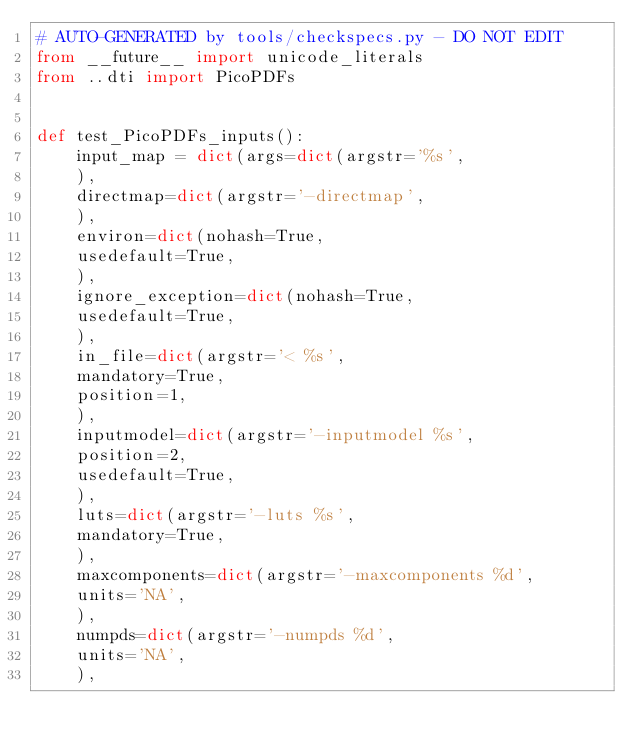<code> <loc_0><loc_0><loc_500><loc_500><_Python_># AUTO-GENERATED by tools/checkspecs.py - DO NOT EDIT
from __future__ import unicode_literals
from ..dti import PicoPDFs


def test_PicoPDFs_inputs():
    input_map = dict(args=dict(argstr='%s',
    ),
    directmap=dict(argstr='-directmap',
    ),
    environ=dict(nohash=True,
    usedefault=True,
    ),
    ignore_exception=dict(nohash=True,
    usedefault=True,
    ),
    in_file=dict(argstr='< %s',
    mandatory=True,
    position=1,
    ),
    inputmodel=dict(argstr='-inputmodel %s',
    position=2,
    usedefault=True,
    ),
    luts=dict(argstr='-luts %s',
    mandatory=True,
    ),
    maxcomponents=dict(argstr='-maxcomponents %d',
    units='NA',
    ),
    numpds=dict(argstr='-numpds %d',
    units='NA',
    ),</code> 